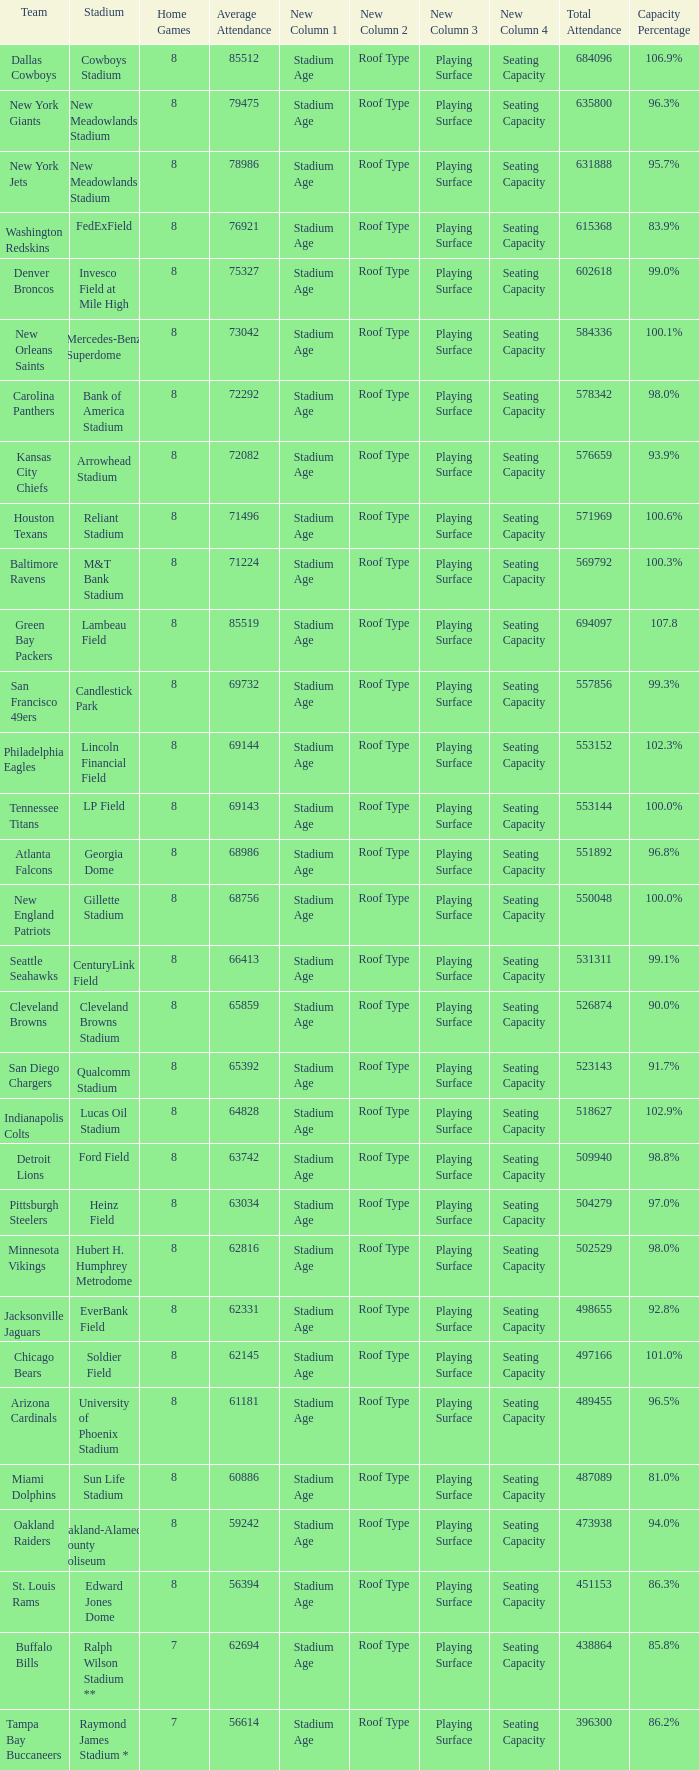What is the name of the team when the stadium is listed as Edward Jones Dome? St. Louis Rams. Give me the full table as a dictionary. {'header': ['Team', 'Stadium', 'Home Games', 'Average Attendance', 'New Column 1', 'New Column 2', 'New Column 3', 'New Column 4', 'Total Attendance', 'Capacity Percentage'], 'rows': [['Dallas Cowboys', 'Cowboys Stadium', '8', '85512', 'Stadium Age', 'Roof Type', 'Playing Surface', 'Seating Capacity', '684096', '106.9%'], ['New York Giants', 'New Meadowlands Stadium', '8', '79475', 'Stadium Age', 'Roof Type', 'Playing Surface', 'Seating Capacity', '635800', '96.3%'], ['New York Jets', 'New Meadowlands Stadium', '8', '78986', 'Stadium Age', 'Roof Type', 'Playing Surface', 'Seating Capacity', '631888', '95.7%'], ['Washington Redskins', 'FedExField', '8', '76921', 'Stadium Age', 'Roof Type', 'Playing Surface', 'Seating Capacity', '615368', '83.9%'], ['Denver Broncos', 'Invesco Field at Mile High', '8', '75327', 'Stadium Age', 'Roof Type', 'Playing Surface', 'Seating Capacity', '602618', '99.0%'], ['New Orleans Saints', 'Mercedes-Benz Superdome', '8', '73042', 'Stadium Age', 'Roof Type', 'Playing Surface', 'Seating Capacity', '584336', '100.1%'], ['Carolina Panthers', 'Bank of America Stadium', '8', '72292', 'Stadium Age', 'Roof Type', 'Playing Surface', 'Seating Capacity', '578342', '98.0%'], ['Kansas City Chiefs', 'Arrowhead Stadium', '8', '72082', 'Stadium Age', 'Roof Type', 'Playing Surface', 'Seating Capacity', '576659', '93.9%'], ['Houston Texans', 'Reliant Stadium', '8', '71496', 'Stadium Age', 'Roof Type', 'Playing Surface', 'Seating Capacity', '571969', '100.6%'], ['Baltimore Ravens', 'M&T Bank Stadium', '8', '71224', 'Stadium Age', 'Roof Type', 'Playing Surface', 'Seating Capacity', '569792', '100.3%'], ['Green Bay Packers', 'Lambeau Field', '8', '85519', 'Stadium Age', 'Roof Type', 'Playing Surface', 'Seating Capacity', '694097', '107.8'], ['San Francisco 49ers', 'Candlestick Park', '8', '69732', 'Stadium Age', 'Roof Type', 'Playing Surface', 'Seating Capacity', '557856', '99.3%'], ['Philadelphia Eagles', 'Lincoln Financial Field', '8', '69144', 'Stadium Age', 'Roof Type', 'Playing Surface', 'Seating Capacity', '553152', '102.3%'], ['Tennessee Titans', 'LP Field', '8', '69143', 'Stadium Age', 'Roof Type', 'Playing Surface', 'Seating Capacity', '553144', '100.0%'], ['Atlanta Falcons', 'Georgia Dome', '8', '68986', 'Stadium Age', 'Roof Type', 'Playing Surface', 'Seating Capacity', '551892', '96.8%'], ['New England Patriots', 'Gillette Stadium', '8', '68756', 'Stadium Age', 'Roof Type', 'Playing Surface', 'Seating Capacity', '550048', '100.0%'], ['Seattle Seahawks', 'CenturyLink Field', '8', '66413', 'Stadium Age', 'Roof Type', 'Playing Surface', 'Seating Capacity', '531311', '99.1%'], ['Cleveland Browns', 'Cleveland Browns Stadium', '8', '65859', 'Stadium Age', 'Roof Type', 'Playing Surface', 'Seating Capacity', '526874', '90.0%'], ['San Diego Chargers', 'Qualcomm Stadium', '8', '65392', 'Stadium Age', 'Roof Type', 'Playing Surface', 'Seating Capacity', '523143', '91.7%'], ['Indianapolis Colts', 'Lucas Oil Stadium', '8', '64828', 'Stadium Age', 'Roof Type', 'Playing Surface', 'Seating Capacity', '518627', '102.9%'], ['Detroit Lions', 'Ford Field', '8', '63742', 'Stadium Age', 'Roof Type', 'Playing Surface', 'Seating Capacity', '509940', '98.8%'], ['Pittsburgh Steelers', 'Heinz Field', '8', '63034', 'Stadium Age', 'Roof Type', 'Playing Surface', 'Seating Capacity', '504279', '97.0%'], ['Minnesota Vikings', 'Hubert H. Humphrey Metrodome', '8', '62816', 'Stadium Age', 'Roof Type', 'Playing Surface', 'Seating Capacity', '502529', '98.0%'], ['Jacksonville Jaguars', 'EverBank Field', '8', '62331', 'Stadium Age', 'Roof Type', 'Playing Surface', 'Seating Capacity', '498655', '92.8%'], ['Chicago Bears', 'Soldier Field', '8', '62145', 'Stadium Age', 'Roof Type', 'Playing Surface', 'Seating Capacity', '497166', '101.0%'], ['Arizona Cardinals', 'University of Phoenix Stadium', '8', '61181', 'Stadium Age', 'Roof Type', 'Playing Surface', 'Seating Capacity', '489455', '96.5%'], ['Miami Dolphins', 'Sun Life Stadium', '8', '60886', 'Stadium Age', 'Roof Type', 'Playing Surface', 'Seating Capacity', '487089', '81.0%'], ['Oakland Raiders', 'Oakland-Alameda County Coliseum', '8', '59242', 'Stadium Age', 'Roof Type', 'Playing Surface', 'Seating Capacity', '473938', '94.0%'], ['St. Louis Rams', 'Edward Jones Dome', '8', '56394', 'Stadium Age', 'Roof Type', 'Playing Surface', 'Seating Capacity', '451153', '86.3%'], ['Buffalo Bills', 'Ralph Wilson Stadium **', '7', '62694', 'Stadium Age', 'Roof Type', 'Playing Surface', 'Seating Capacity', '438864', '85.8%'], ['Tampa Bay Buccaneers', 'Raymond James Stadium *', '7', '56614', 'Stadium Age', 'Roof Type', 'Playing Surface', 'Seating Capacity', '396300', '86.2%']]} 